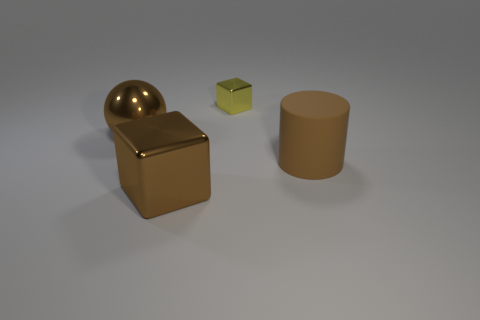There is a object on the right side of the cube that is behind the brown cylinder on the right side of the brown metallic block; what is it made of?
Provide a succinct answer. Rubber. Are the large cube and the yellow object on the left side of the large cylinder made of the same material?
Your answer should be compact. Yes. There is a object that is on the right side of the brown block and in front of the tiny metal block; what is its color?
Offer a terse response. Brown. What number of cylinders are either tiny red rubber objects or tiny yellow things?
Give a very brief answer. 0. There is a yellow metallic thing; is its shape the same as the brown shiny thing that is on the right side of the brown metal sphere?
Ensure brevity in your answer.  Yes. There is a shiny thing that is on the right side of the brown ball and behind the large shiny cube; what size is it?
Provide a short and direct response. Small. The tiny thing is what shape?
Offer a very short reply. Cube. There is a object behind the metallic sphere; is there a object that is in front of it?
Provide a short and direct response. Yes. How many brown metallic balls are behind the block behind the rubber thing?
Your response must be concise. 0. There is a cylinder that is the same size as the brown cube; what is its material?
Offer a very short reply. Rubber. 